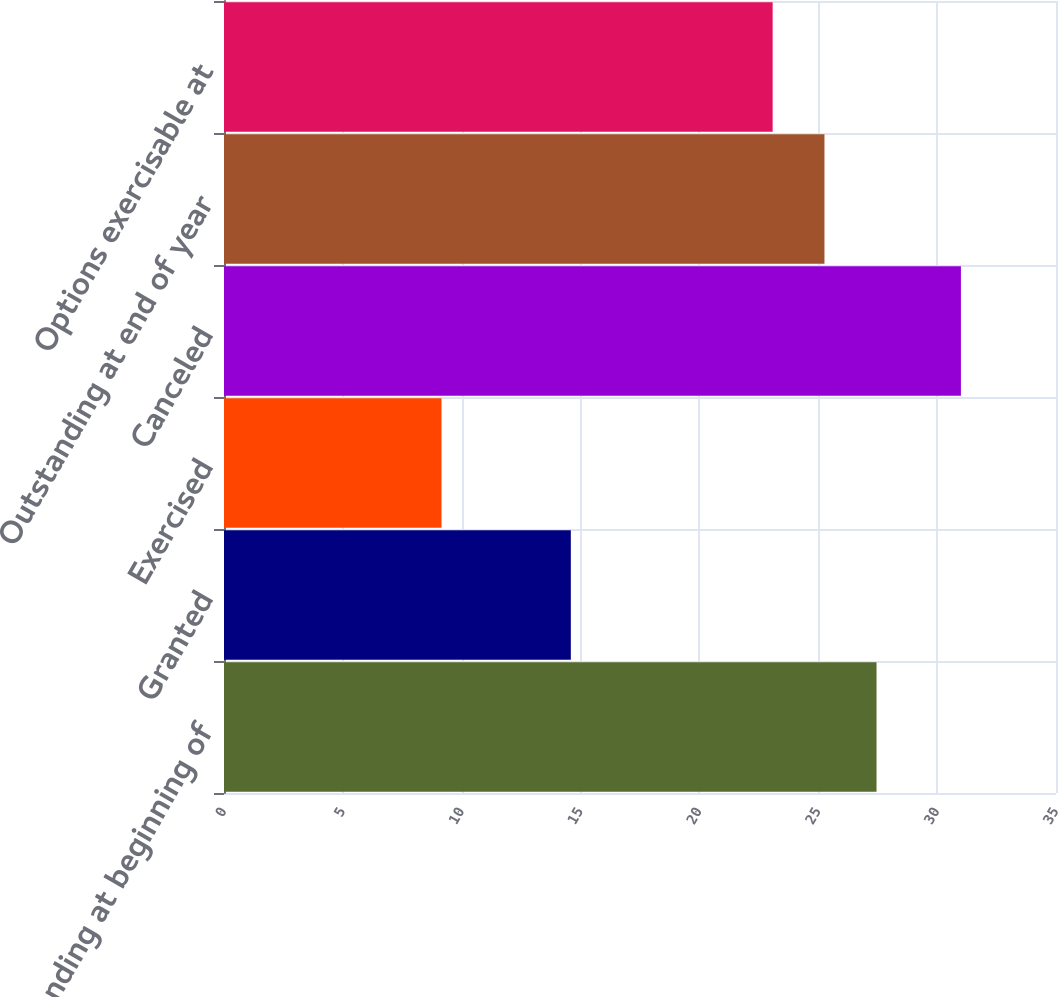<chart> <loc_0><loc_0><loc_500><loc_500><bar_chart><fcel>Outstanding at beginning of<fcel>Granted<fcel>Exercised<fcel>Canceled<fcel>Outstanding at end of year<fcel>Options exercisable at<nl><fcel>27.45<fcel>14.59<fcel>9.15<fcel>31<fcel>25.26<fcel>23.08<nl></chart> 